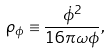<formula> <loc_0><loc_0><loc_500><loc_500>\rho _ { \phi } \equiv \frac { \dot { \phi } ^ { 2 } } { 1 6 \pi \omega \phi } ,</formula> 